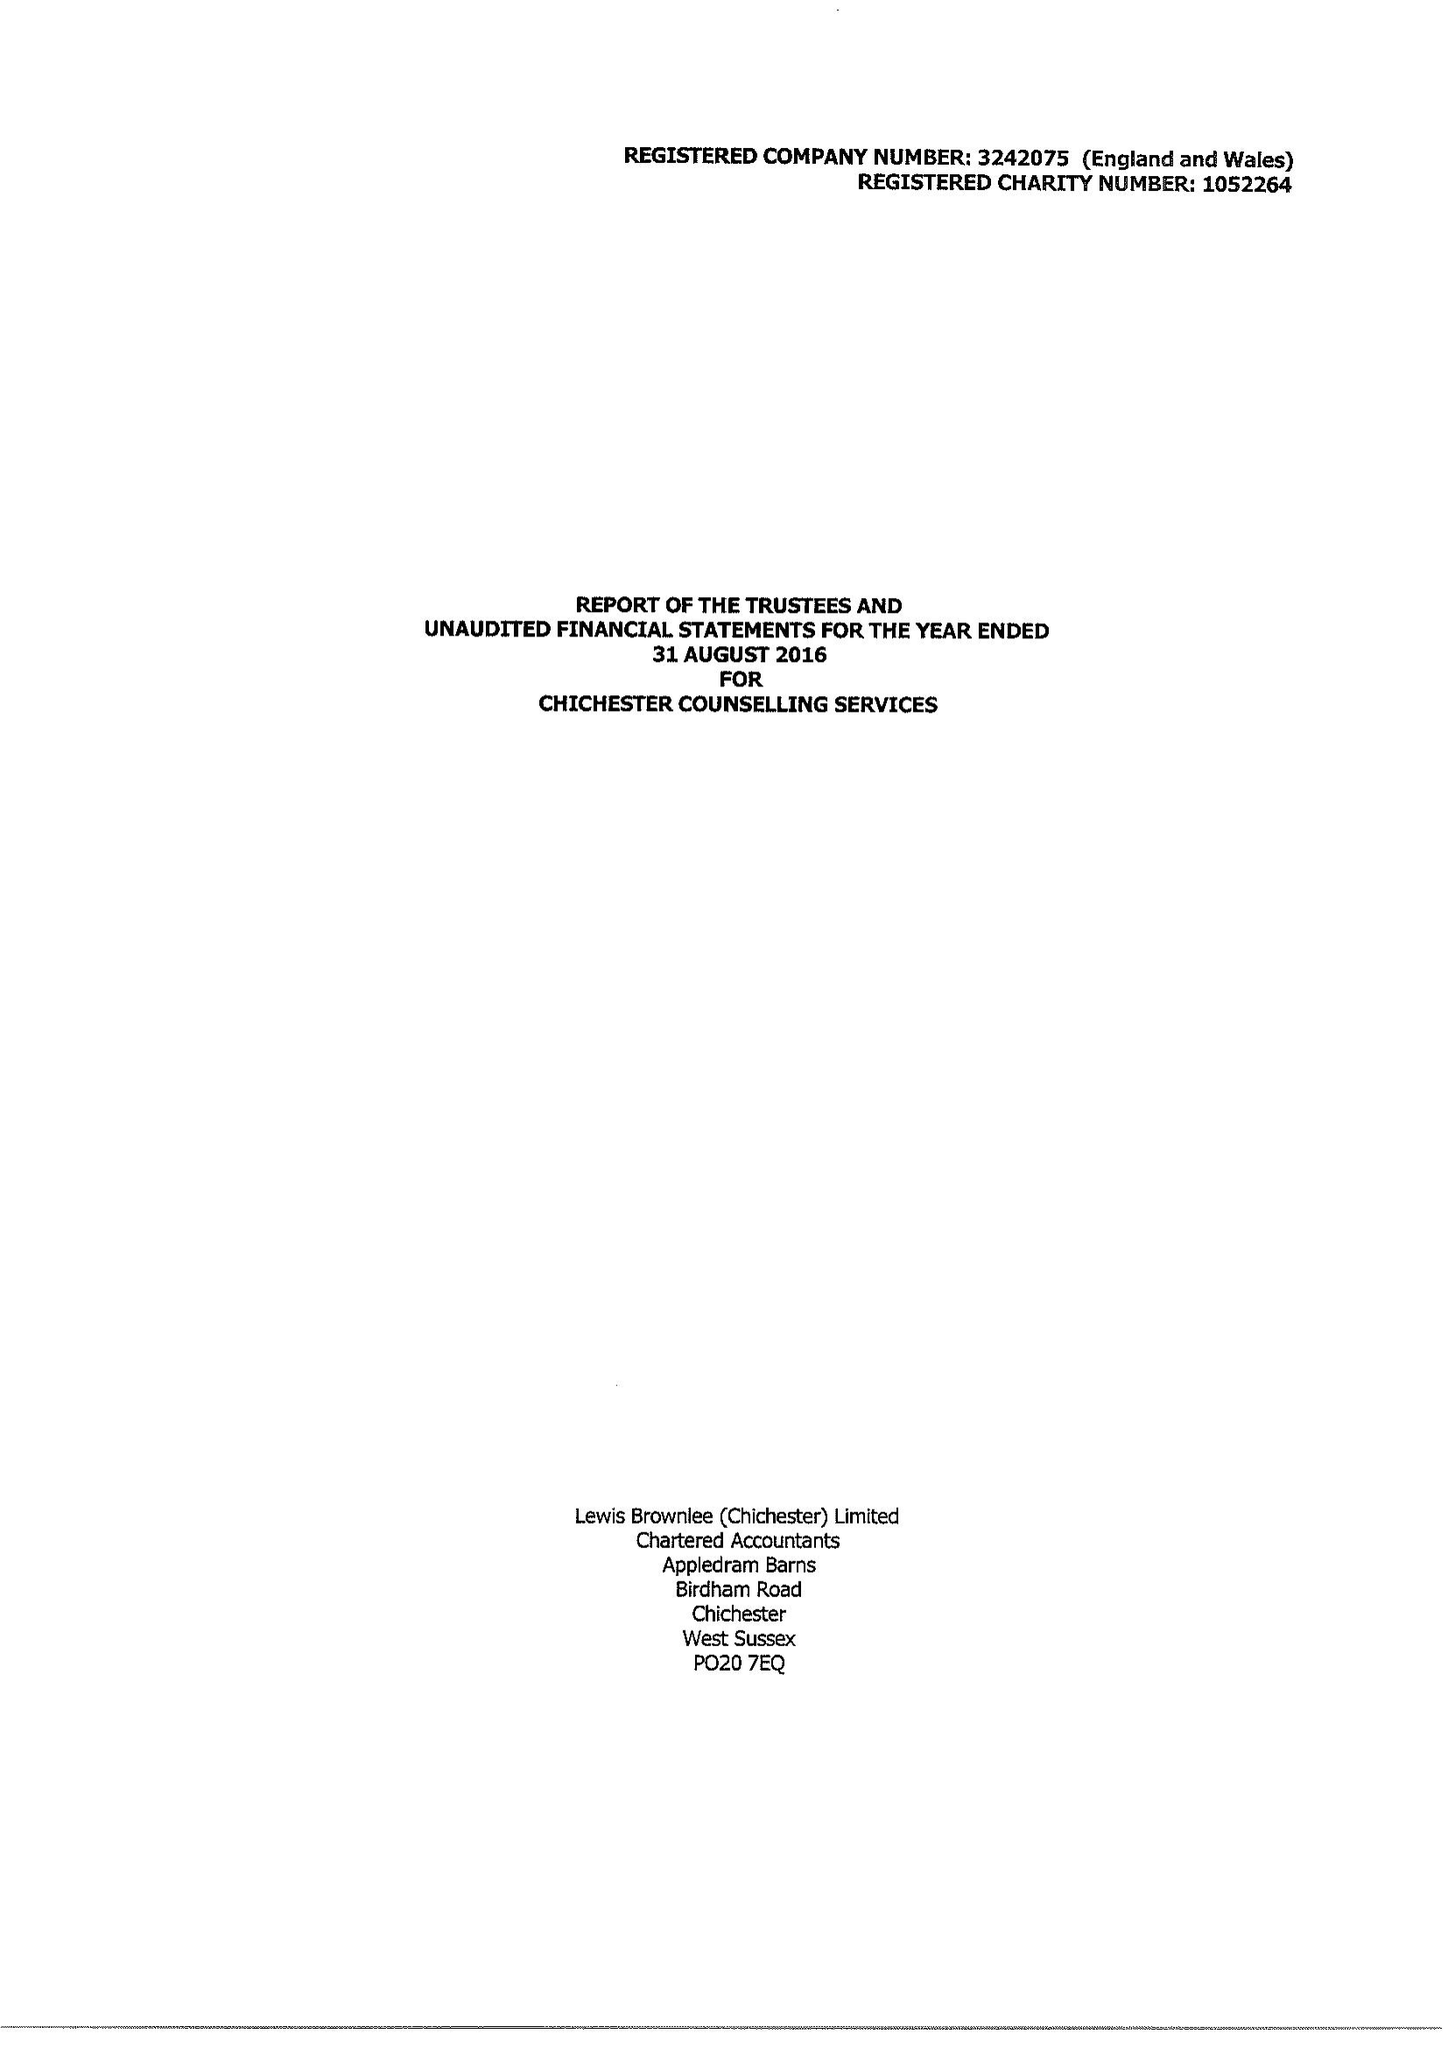What is the value for the address__post_town?
Answer the question using a single word or phrase. None 